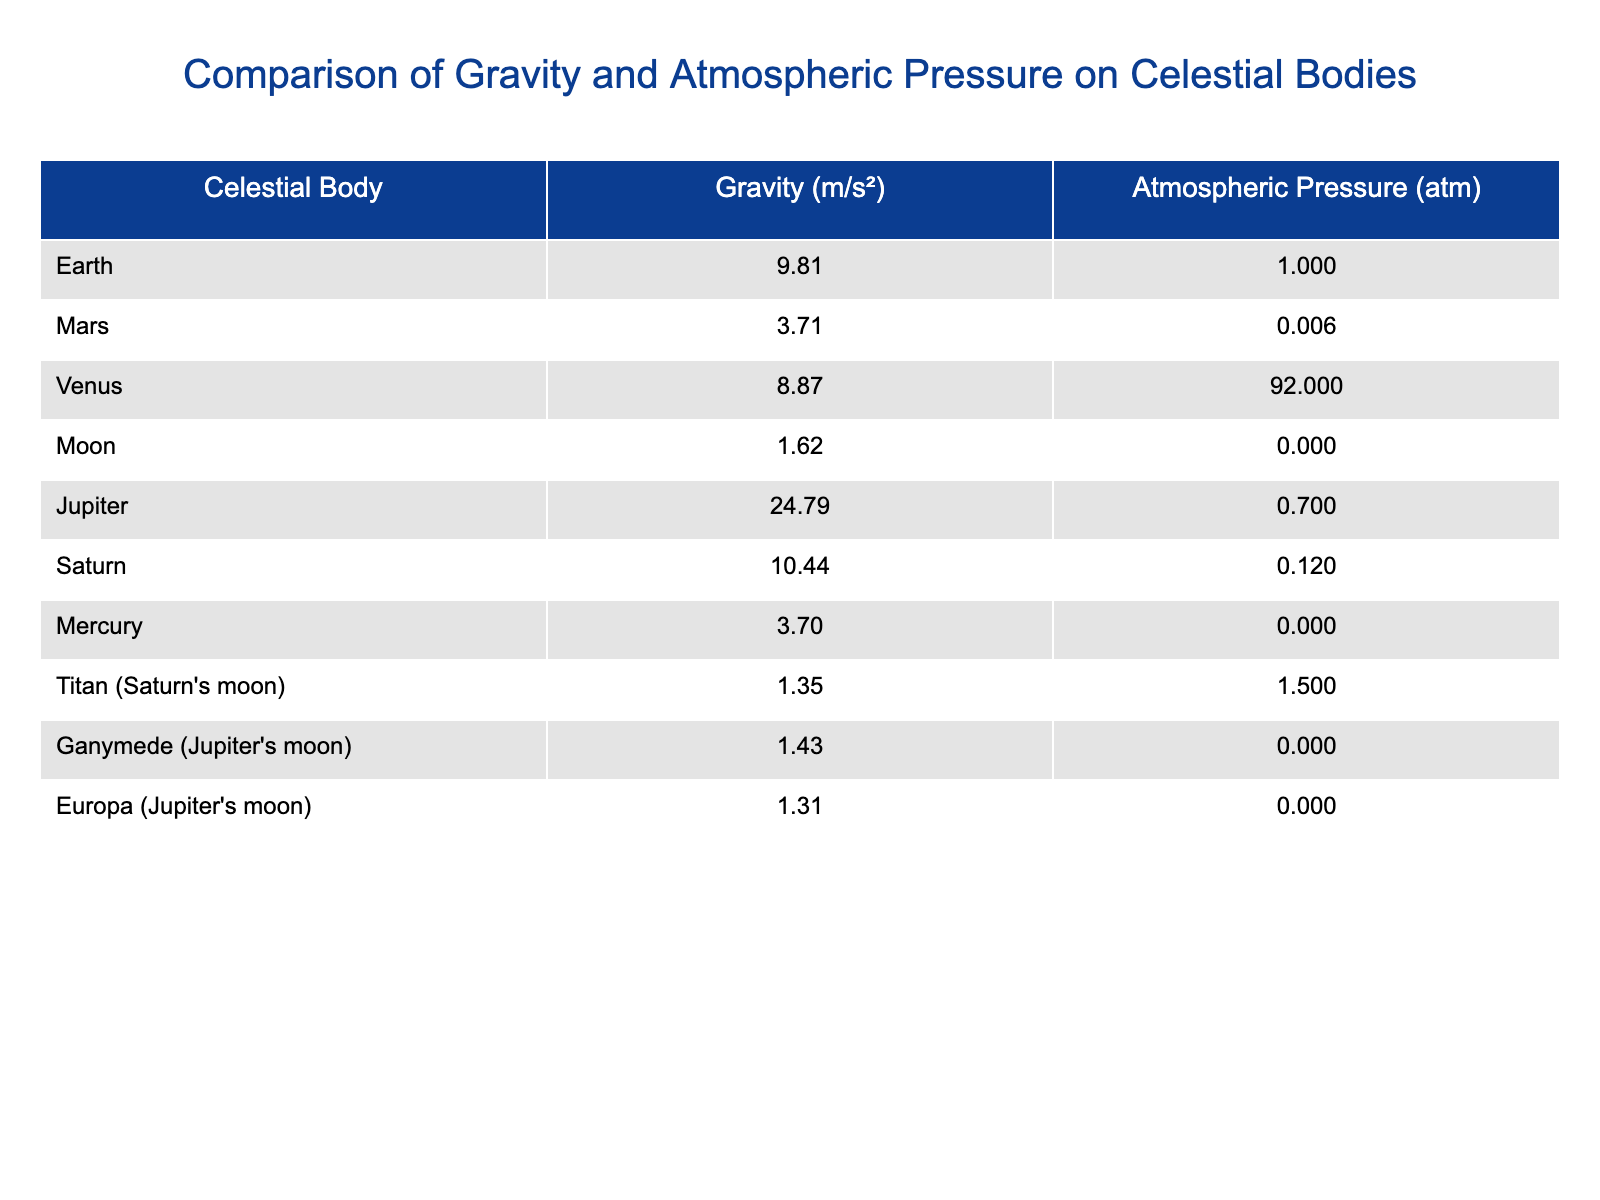What is the atmospheric pressure on Mars? The table lists the atmospheric pressure for Mars as 0.006 atm. It is found in the row corresponding to Mars in the "Atmospheric Pressure" column.
Answer: 0.006 atm Which celestial body has the highest gravity? According to the table, Jupiter has the highest gravity, listed at 24.79 m/s², found in the row for Jupiter in the "Gravity" column.
Answer: Jupiter Is the atmospheric pressure on Titan higher than that on Earth? The atmospheric pressure on Titan is 1.50 atm, compared to Earth's 1.00 atm. Since 1.50 atm is greater than 1.00 atm, the answer is yes.
Answer: Yes What is the difference in gravity between Earth and the Moon? Earth's gravity is 9.81 m/s² and the Moon's gravity is 1.62 m/s². To find the difference, subtract the Moon's gravity from Earth's: 9.81 - 1.62 = 8.19 m/s².
Answer: 8.19 m/s² Which celestial body has the lowest atmospheric pressure? From the table, the Moon and Mercury both have an atmospheric pressure of 0.000 atm, which is the lowest in the list.
Answer: Moon and Mercury What is the average gravity across all the celestial bodies listed? The sum of all gravity values is 9.81 + 3.71 + 8.87 + 1.62 + 24.79 + 10.44 + 3.70 + 1.35 + 1.43 + 1.31 =  66.751 m/s². There are 10 celestial bodies, so the average is 66.751 / 10 = 6.6751 m/s².
Answer: 6.68 m/s² Does Venus have a lower atmospheric pressure than Jupiter? Venus's atmospheric pressure is 92.00 atm while Jupiter's is 0.70 atm. Since 92.00 atm is greater than 0.70 atm, the answer is no.
Answer: No What celestial body has gravity closest to that of the Moon? The Moon has a gravity of 1.62 m/s², and the celestial body with gravity closest to this is Titan, which has a gravity of 1.35 m/s².
Answer: Titan 